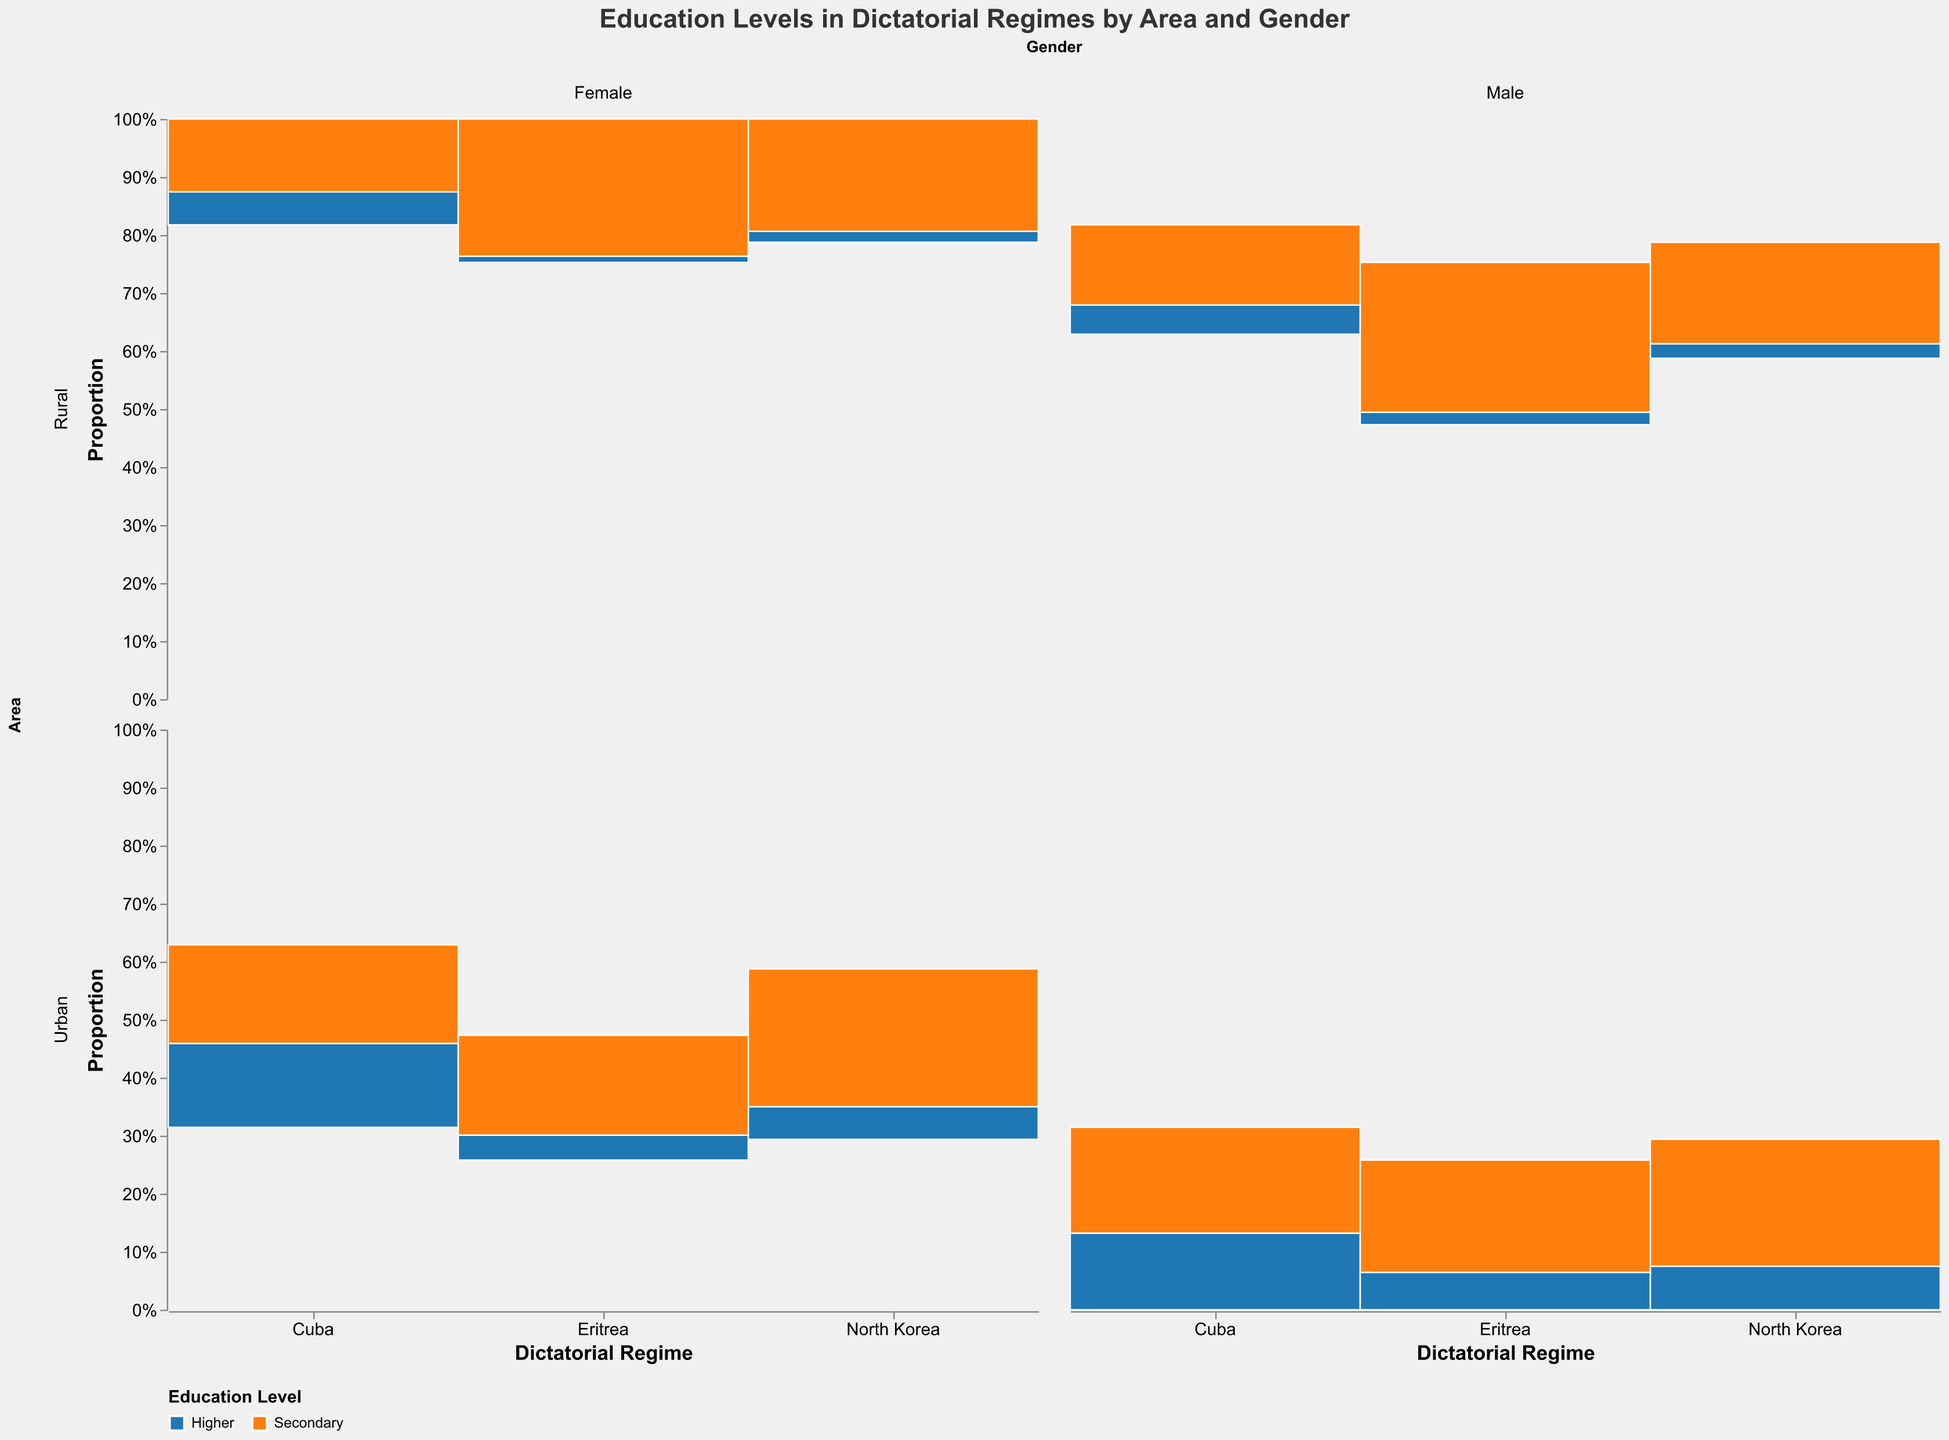How many males in urban North Korea have a higher education level? Look at the segment for urban males in the North Korea section and the blue color represents higher education level. The count is 120.
Answer: 120 Which gender has a higher proportion of higher education in urban Cuba? Compare the blue segments for males and females in the urban section of Cuba. The female segment is slightly larger.
Answer: Female What is the total count of people with secondary education in rural Eritrea? Add the orange segments for males and females in the rural Eritrea section: 240 (males) + 220 (females) = 460.
Answer: 460 Which area has a higher number of individuals with higher education in North Korea, urban or rural? Compare the blue segments between urban and rural North Korea. Urban areas have noticeably larger blue segments.
Answer: Urban In Cuba, which educational level is more prevalent in rural males? Compare the blue and orange segments for rural males in Cuba. The orange segment is larger, indicating secondary education is more prevalent.
Answer: Secondary How does the number of females with higher education in urban Eritrea compare to rural Eritrea? Compare the blue segments for urban and rural females in Eritrea. The urban segment is larger than the rural segment.
Answer: Urban Eritrea has more females with higher education What is the difference in the count of females with secondary education between urban and rural North Korea? Compare the orange segments for females in urban and rural North Korea: 380 (urban) - 310 (rural) = 70.
Answer: 70 Does North Korea or Cuba have a larger proportion of individuals with secondary education overall? Compare the aggregate height of the orange segments in North Korea and Cuba. North Korea shows a larger proportion for secondary education.
Answer: North Korea What is the total number of individuals with higher education in rural areas across all regimes? Add the blue segments for rural areas across all regimes: North Korea (40 + 30) + Cuba (80 + 90) + Eritrea (20 + 10) = 270.
Answer: 270 Which regime has the smallest proportion of higher education among rural females? Look at the smallest blue segment for rural females. Eritrea's segment is the smallest.
Answer: Eritrea 